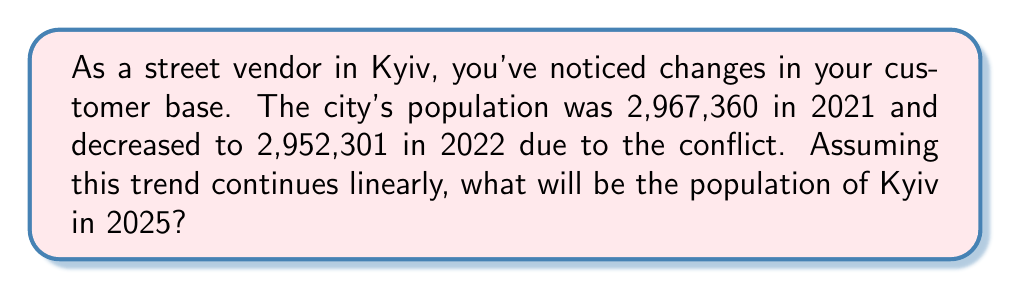Teach me how to tackle this problem. Let's approach this step-by-step:

1) First, we need to calculate the rate of population change per year:
   $$\text{Rate of change} = \frac{\text{Change in population}}{\text{Time interval}}$$
   $$= \frac{2,952,301 - 2,967,360}{2022 - 2021} = -15,059 \text{ people per year}$$

2) Now, we need to project this change over 3 years (from 2022 to 2025):
   $$\text{Total change} = -15,059 \times 3 = -45,177$$

3) Finally, we add this change to the 2022 population:
   $$\text{2025 population} = 2,952,301 + (-45,177) = 2,907,124$$

Therefore, if this linear trend continues, the population of Kyiv in 2025 would be approximately 2,907,124.
Answer: 2,907,124 